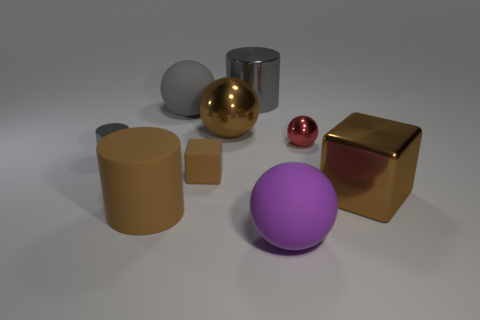Subtract all cylinders. How many objects are left? 6 Subtract 1 purple balls. How many objects are left? 8 Subtract all cyan things. Subtract all gray matte spheres. How many objects are left? 8 Add 9 large shiny balls. How many large shiny balls are left? 10 Add 5 small matte blocks. How many small matte blocks exist? 6 